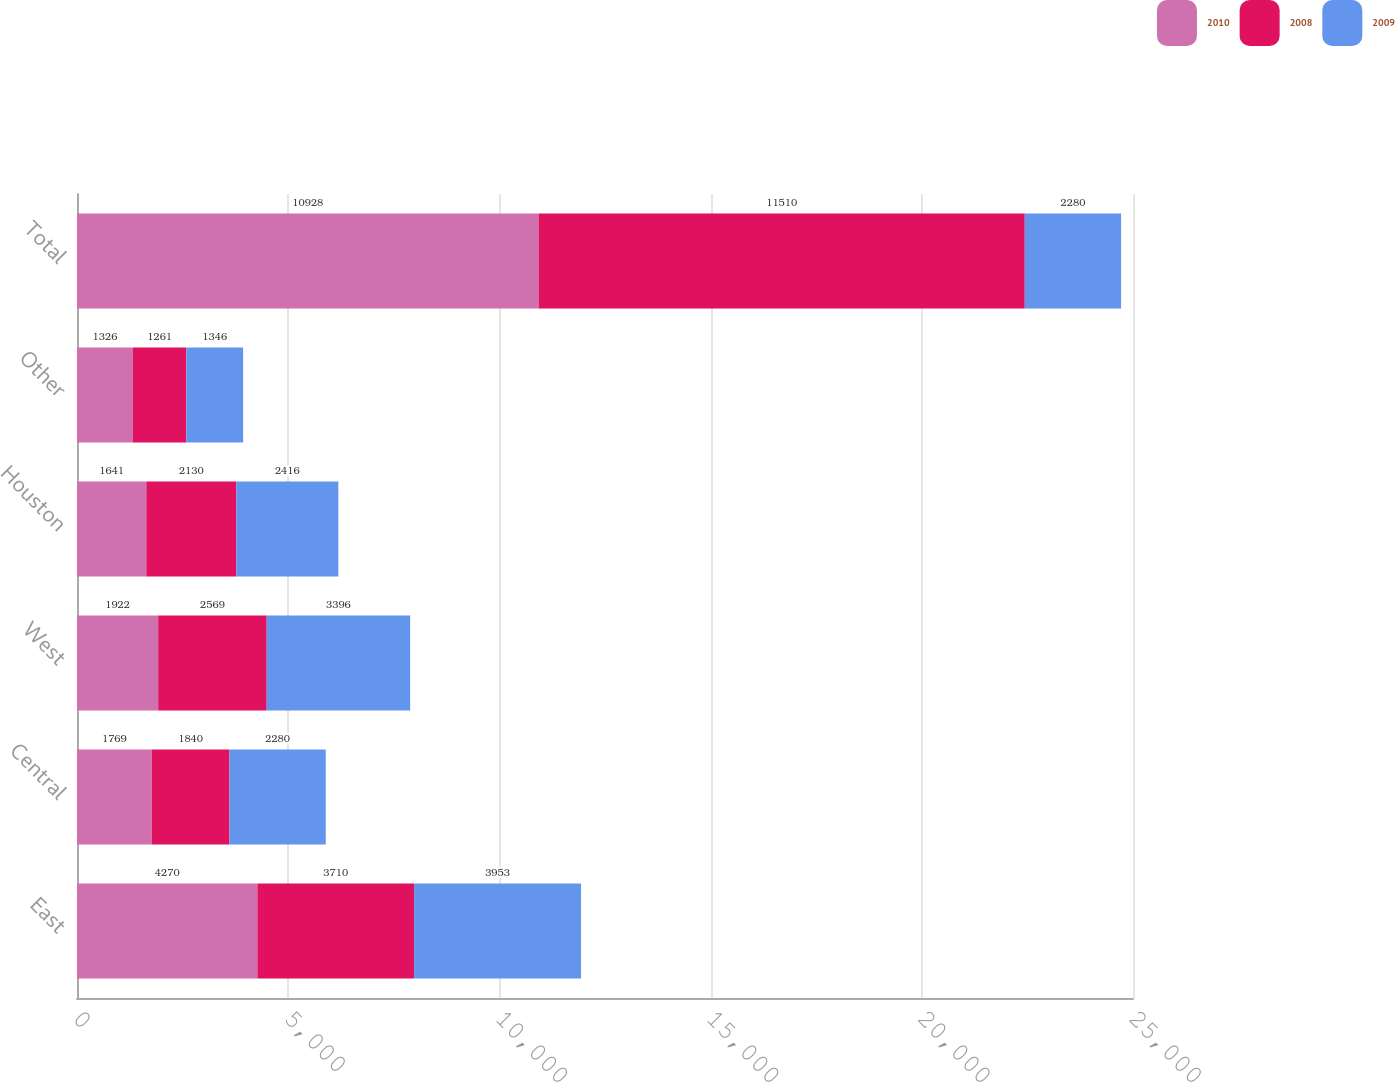<chart> <loc_0><loc_0><loc_500><loc_500><stacked_bar_chart><ecel><fcel>East<fcel>Central<fcel>West<fcel>Houston<fcel>Other<fcel>Total<nl><fcel>2010<fcel>4270<fcel>1769<fcel>1922<fcel>1641<fcel>1326<fcel>10928<nl><fcel>2008<fcel>3710<fcel>1840<fcel>2569<fcel>2130<fcel>1261<fcel>11510<nl><fcel>2009<fcel>3953<fcel>2280<fcel>3396<fcel>2416<fcel>1346<fcel>2280<nl></chart> 